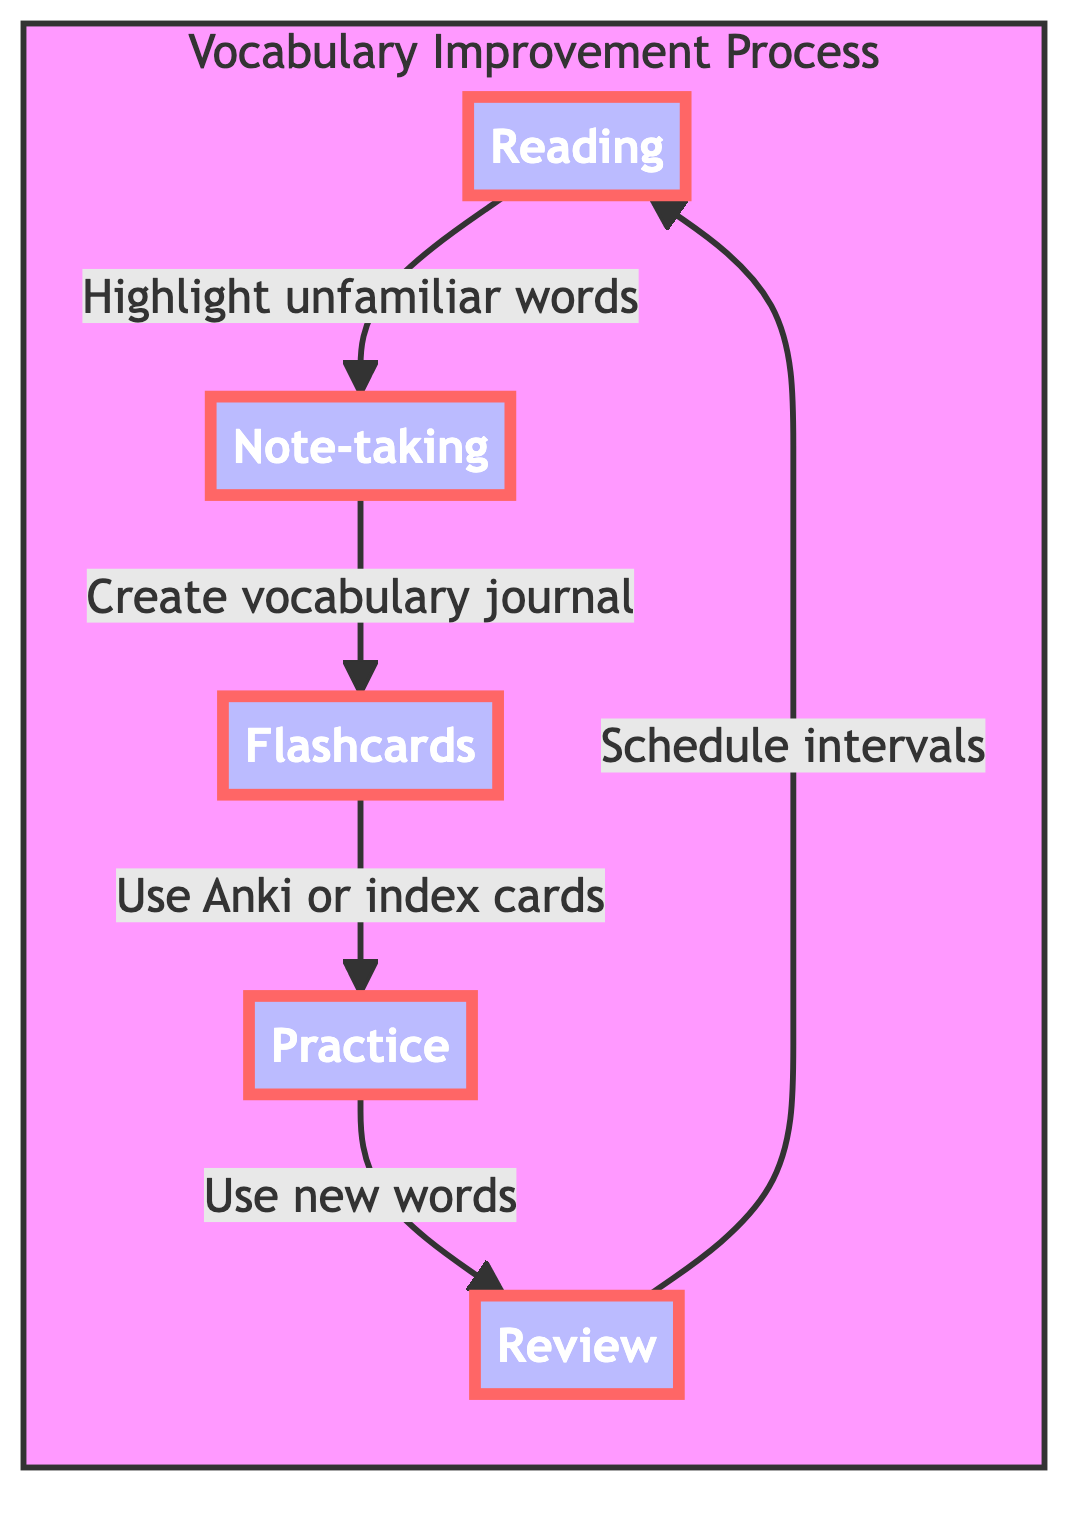What is the first step in the vocabulary improvement process? The first step is indicated in the diagram as 'Reading.' It is the starting point of the flowchart, where the process begins.
Answer: Reading How many steps are in the vocabulary improvement process? The flowchart contains five distinct steps, each represented by a node in the horizontal layout.
Answer: 5 What comes after Note-taking? The flowchart shows that the step following 'Note-taking' is 'Flashcards,' as indicated by the directed arrow leading from Note-taking to Flashcards.
Answer: Flashcards What is the last step in the vocabulary improvement process? The last step is represented in the diagram by 'Review.' This is where the process concludes.
Answer: Review Which tool can be used for creating flashcards? The diagram mentions using 'Anki or index cards' to create flashcards, which are two methods indicated for this step.
Answer: Anki or index cards What type of activities are suggested during the Practice step? The Practice step encourages engaging in 'activities to practice your new vocabulary,' which includes using the new words in sentences and writing.
Answer: Activities to practice vocabulary Which step emphasizes the importance of scheduling? The Review step is the one that emphasizes the need to 'Schedule intervals' for regular reinforcement of memory regarding vocabulary.
Answer: Review How are the steps connected in this flowchart? The flowchart is structured as a sequential process where each step flows into the next, indicated by directed arrows linking the nodes.
Answer: Sequential process 